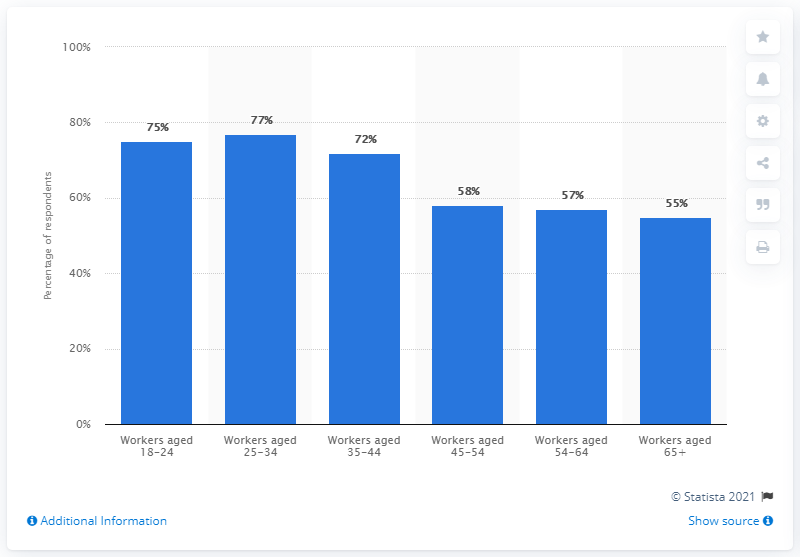Specify some key components in this picture. In the 35-44 age group, 72% of individuals purchased lunch at work. 